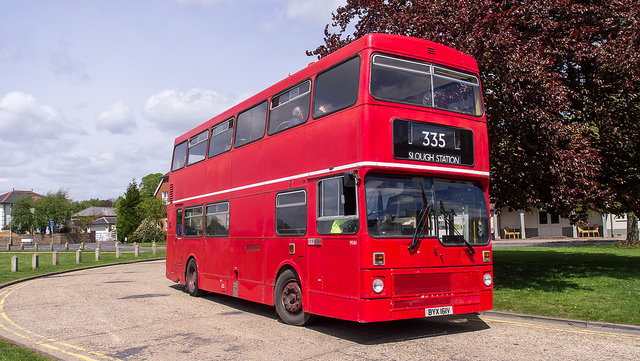Extract all visible text content from this image. 335 SLOUGH Station SYX16 